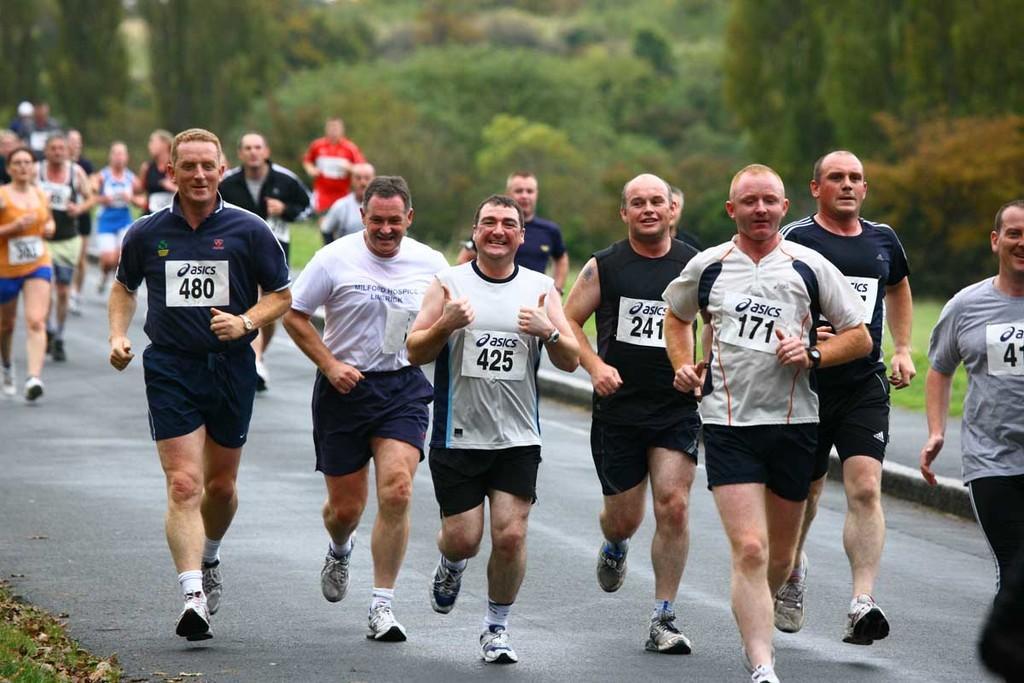Describe this image in one or two sentences. In the picture we can see a road on it, we can see some men are running and they are wearing a T-shirt and numbers to it and some set of people are also running behind them and beside the road we can see grass surface and on it we can see some plants, trees. 